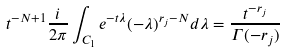Convert formula to latex. <formula><loc_0><loc_0><loc_500><loc_500>t ^ { - N + 1 } \frac { i } { 2 \pi } \int _ { C _ { 1 } } e ^ { - t \lambda } ( - \lambda ) ^ { r _ { j } - N } d \lambda = \frac { t ^ { - r _ { j } } } { \Gamma ( - r _ { j } ) }</formula> 